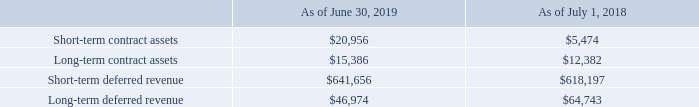Contract Balances
A contract asset will be recorded if we have recognized revenue but do not have an unconditional right to the related consideration from the customer. For example, this will be the case if implementation services offered in a cloud arrangement are identified as a separate performance obligation and are provided to a customer prior to us being able to bill the customer. In addition, a contract asset may arise in relation to subscription licenses if the license revenue that is recognized upfront exceeds the amount that we are able to invoice the customer at that time. Contract assets are reclassified to accounts receivable when the rights become unconditional.
The balance for our contract assets and contract liabilities (i.e. deferred revenues) for the periods indicated below were as follows:
The difference in the opening and closing balances of our contract assets and deferred revenues primarily results from the timing difference between our performance and the customer’s payments. We fulfill our obligations under a contract with a customer by transferring products and services in exchange for consideration from the customer. During the year ended June 30, 2019, we reclassified $19.2 million of contract assets to receivables as a result of the right to the transaction consideration becoming unconditional. During the year ended June 30, 2019, there was no significant impairment loss recognized related to contract assets.
We recognize deferred revenue when we have received consideration or an amount of consideration is due from the customer for future obligations to transfer products or services. Our deferred revenues primarily relate to customer support agreements which have been paid for by customers prior to the performance of those services. The amount of revenue that was recognized during the year ended June 30, 2019 that was included in the deferred revenue balances at July 1, 2018 was approximately $617 million.
What does this table represent? Balance for our contract assets and contract liabilities (i.e. deferred revenues) for the periods indicated. When was $19.2 million of contract assets to receivables as a result of the right to the transaction consideration becoming unconditional reclassified? Year ended june 30, 2019. When will a contract asset be recorded? If we have recognized revenue but do not have an unconditional right to the related consideration from the customer.  What is the total contract assets as of June 30, 2019? 
Answer scale should be: thousand. 20,956 +15,386
Answer: 36342. What is the total deferred revenue as of June 30, 2019?
Answer scale should be: thousand. 641,656+46,974
Answer: 688630. What is the total revenue and assets as of June 30, 2019?
Answer scale should be: thousand. 20,956+15,386+641,656+46,974
Answer: 724972. 